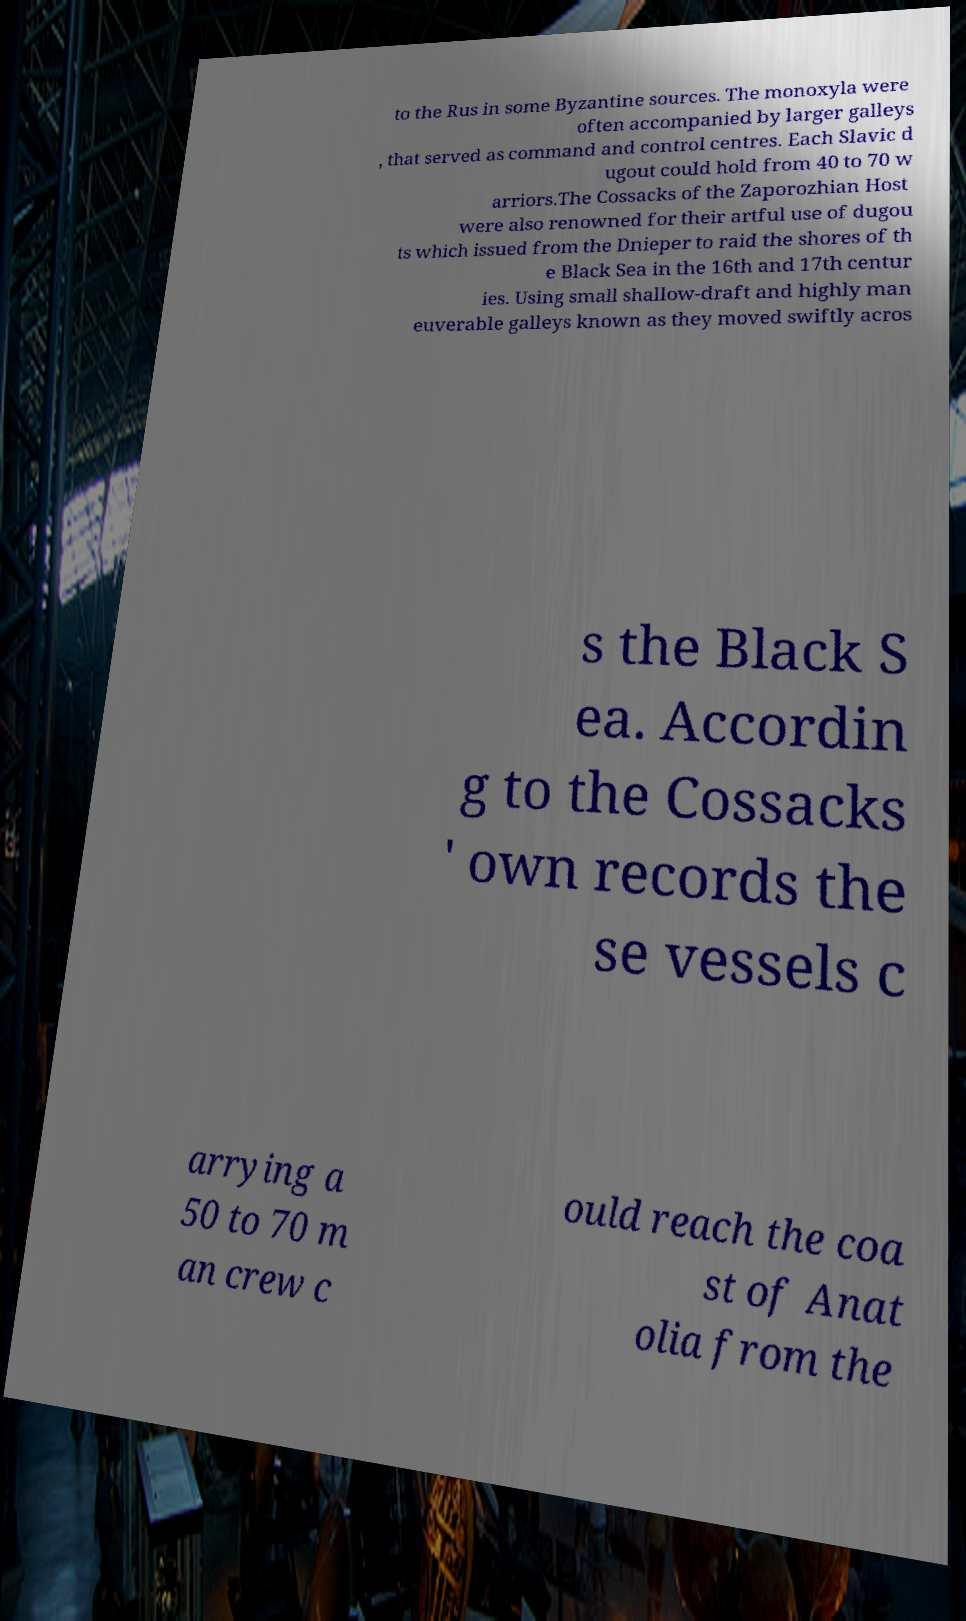Can you accurately transcribe the text from the provided image for me? to the Rus in some Byzantine sources. The monoxyla were often accompanied by larger galleys , that served as command and control centres. Each Slavic d ugout could hold from 40 to 70 w arriors.The Cossacks of the Zaporozhian Host were also renowned for their artful use of dugou ts which issued from the Dnieper to raid the shores of th e Black Sea in the 16th and 17th centur ies. Using small shallow-draft and highly man euverable galleys known as they moved swiftly acros s the Black S ea. Accordin g to the Cossacks ' own records the se vessels c arrying a 50 to 70 m an crew c ould reach the coa st of Anat olia from the 